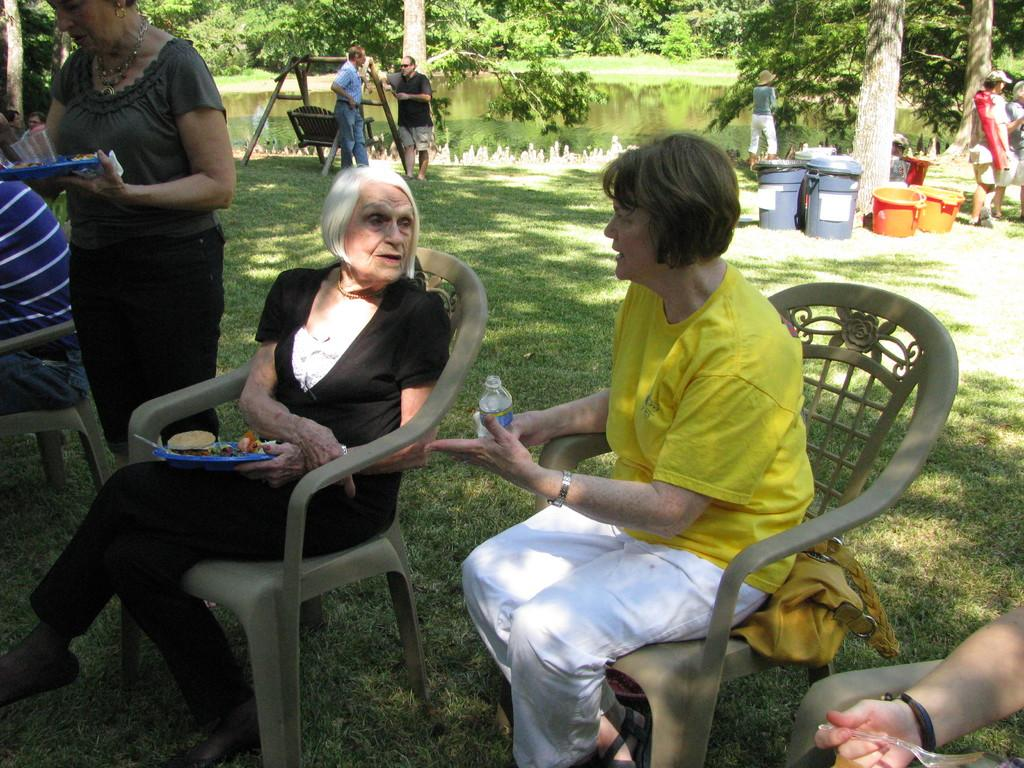What type of vegetation can be seen in the image? There are trees in the image. What natural element is also present in the image? There is water in the image. Are there any human subjects in the image? Yes, there are people in the image. What objects can be seen in the image that are typically used for holding water? There are tubs in the image. What type of ground surface is visible in the image? Grass is present in the image. What type of curtain is hanging from the trees in the image? There is no curtain present in the image; it features trees, water, people, tubs, and grass. What type of tools might a carpenter use in the image? There is no carpenter or tools present in the image. What is the weight of the water in the image? It is not possible to determine the weight of the water in the image, as it is a two-dimensional representation. 